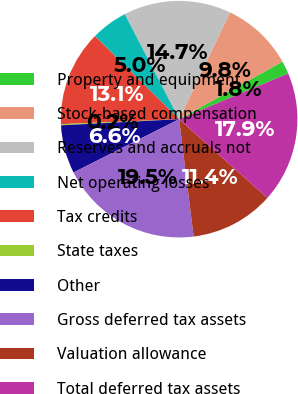Convert chart. <chart><loc_0><loc_0><loc_500><loc_500><pie_chart><fcel>Property and equipment<fcel>Stock-based compensation<fcel>Reserves and accruals not<fcel>Net operating losses<fcel>Tax credits<fcel>State taxes<fcel>Other<fcel>Gross deferred tax assets<fcel>Valuation allowance<fcel>Total deferred tax assets<nl><fcel>1.77%<fcel>9.84%<fcel>14.68%<fcel>5.0%<fcel>13.07%<fcel>0.16%<fcel>6.61%<fcel>19.52%<fcel>11.45%<fcel>17.91%<nl></chart> 